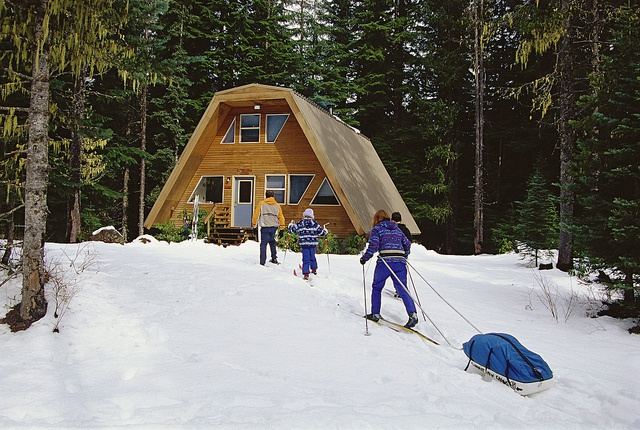Describe the objects in this image and their specific colors. I can see people in olive, navy, black, purple, and darkblue tones, people in olive, darkgray, navy, black, and orange tones, people in olive, navy, black, gray, and darkblue tones, skis in olive, darkgray, gray, and lightgray tones, and people in olive, black, maroon, and brown tones in this image. 